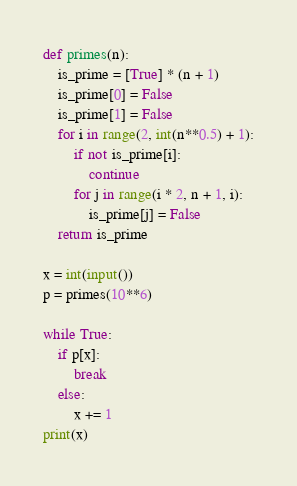Convert code to text. <code><loc_0><loc_0><loc_500><loc_500><_Python_>def primes(n):
    is_prime = [True] * (n + 1)
    is_prime[0] = False
    is_prime[1] = False
    for i in range(2, int(n**0.5) + 1):
        if not is_prime[i]:
            continue
        for j in range(i * 2, n + 1, i):
            is_prime[j] = False
    return is_prime

x = int(input())
p = primes(10**6)

while True:
    if p[x]:
        break
    else:
        x += 1
print(x)</code> 